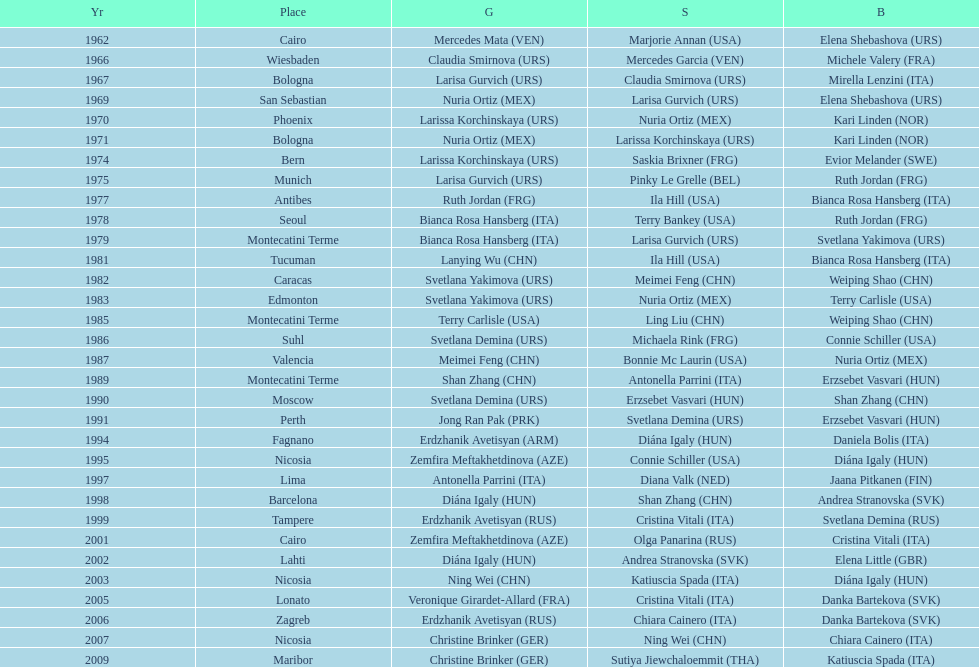Who claimed the exclusive gold medal in 1962? Mercedes Mata. 